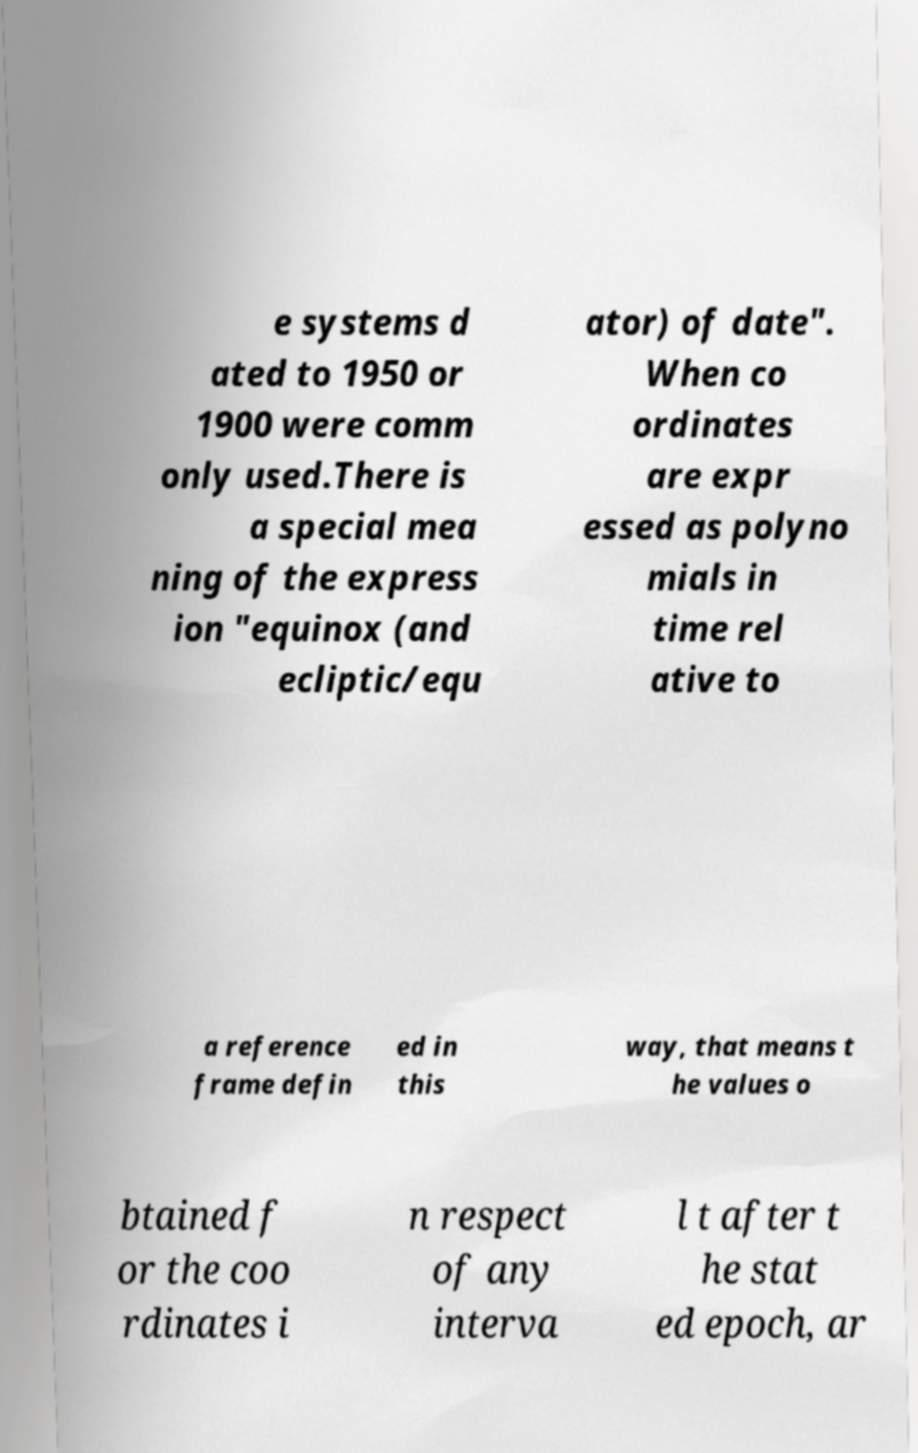I need the written content from this picture converted into text. Can you do that? e systems d ated to 1950 or 1900 were comm only used.There is a special mea ning of the express ion "equinox (and ecliptic/equ ator) of date". When co ordinates are expr essed as polyno mials in time rel ative to a reference frame defin ed in this way, that means t he values o btained f or the coo rdinates i n respect of any interva l t after t he stat ed epoch, ar 